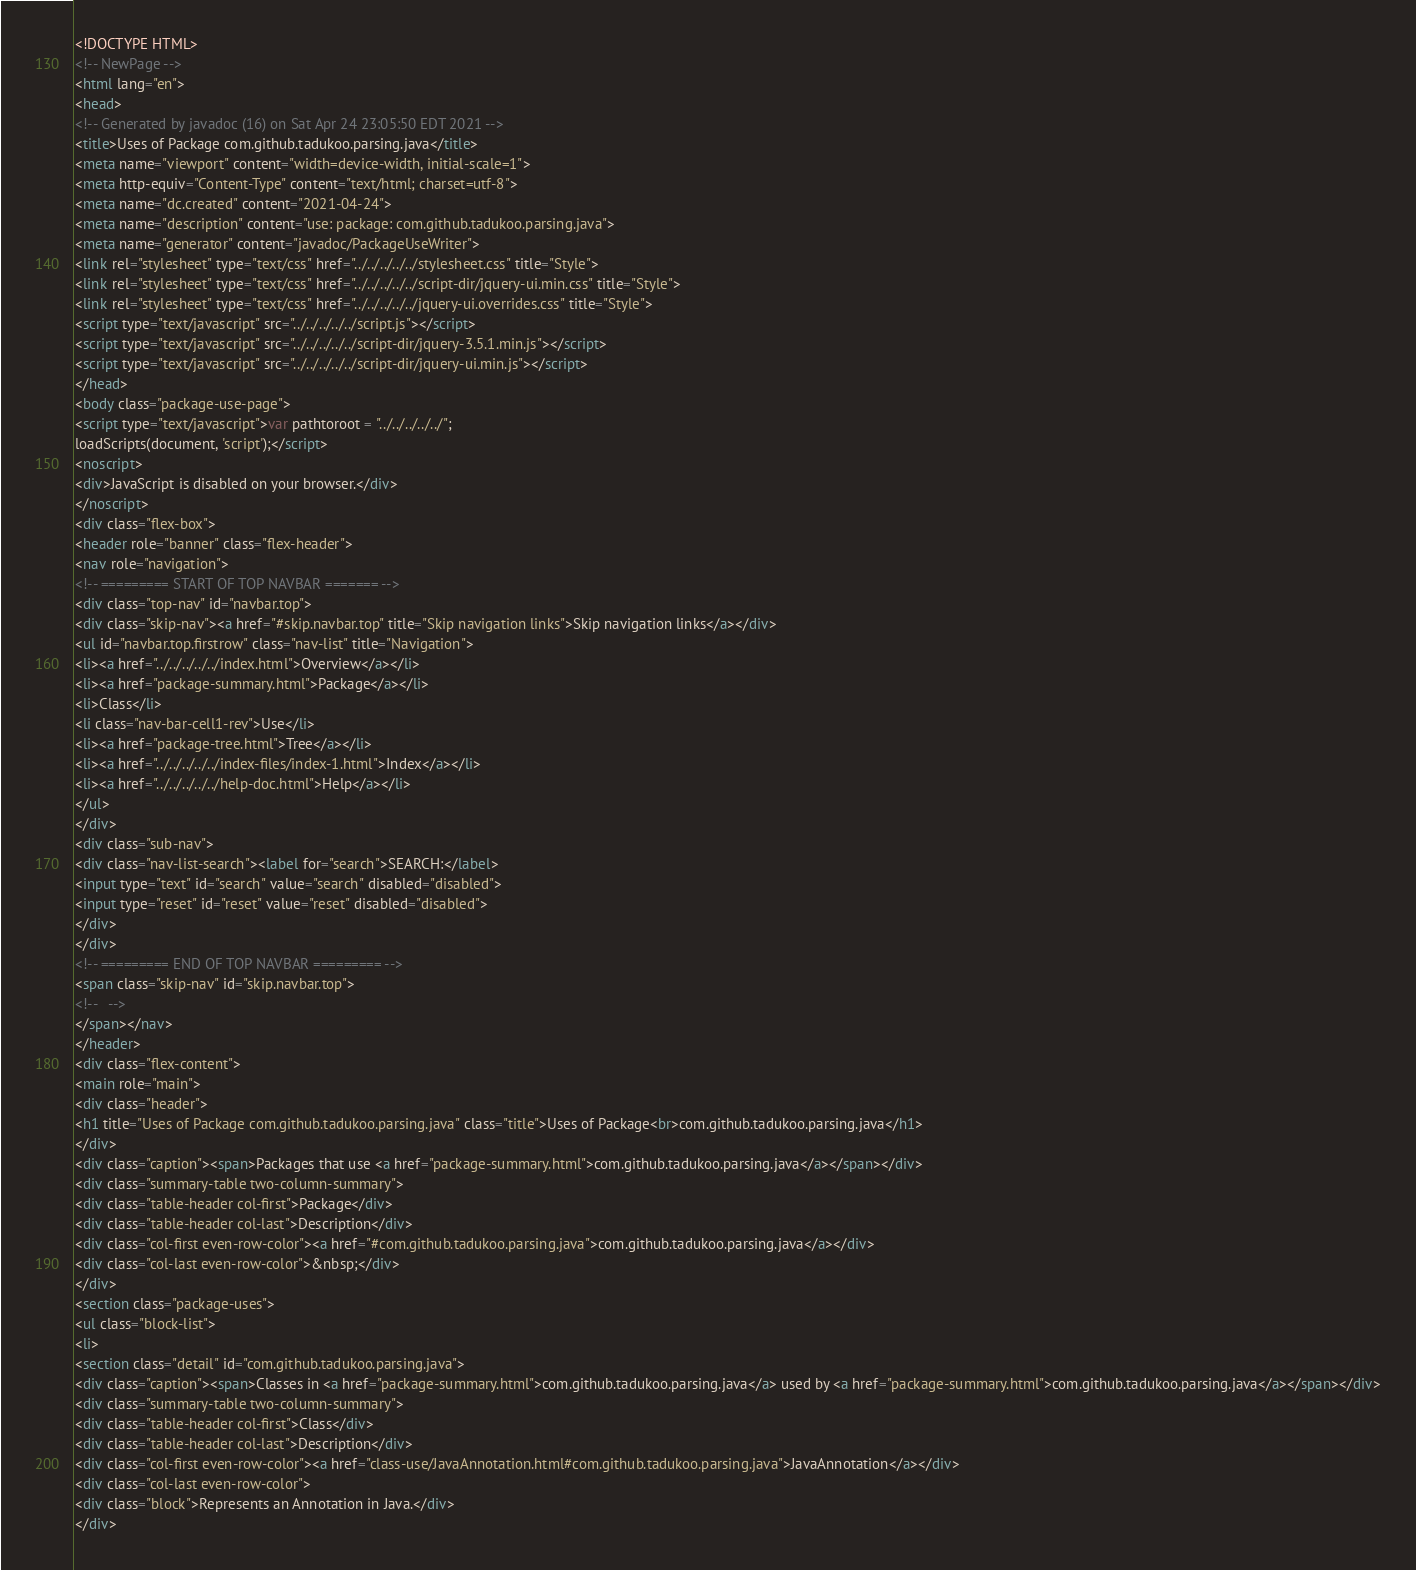<code> <loc_0><loc_0><loc_500><loc_500><_HTML_><!DOCTYPE HTML>
<!-- NewPage -->
<html lang="en">
<head>
<!-- Generated by javadoc (16) on Sat Apr 24 23:05:50 EDT 2021 -->
<title>Uses of Package com.github.tadukoo.parsing.java</title>
<meta name="viewport" content="width=device-width, initial-scale=1">
<meta http-equiv="Content-Type" content="text/html; charset=utf-8">
<meta name="dc.created" content="2021-04-24">
<meta name="description" content="use: package: com.github.tadukoo.parsing.java">
<meta name="generator" content="javadoc/PackageUseWriter">
<link rel="stylesheet" type="text/css" href="../../../../../stylesheet.css" title="Style">
<link rel="stylesheet" type="text/css" href="../../../../../script-dir/jquery-ui.min.css" title="Style">
<link rel="stylesheet" type="text/css" href="../../../../../jquery-ui.overrides.css" title="Style">
<script type="text/javascript" src="../../../../../script.js"></script>
<script type="text/javascript" src="../../../../../script-dir/jquery-3.5.1.min.js"></script>
<script type="text/javascript" src="../../../../../script-dir/jquery-ui.min.js"></script>
</head>
<body class="package-use-page">
<script type="text/javascript">var pathtoroot = "../../../../../";
loadScripts(document, 'script');</script>
<noscript>
<div>JavaScript is disabled on your browser.</div>
</noscript>
<div class="flex-box">
<header role="banner" class="flex-header">
<nav role="navigation">
<!-- ========= START OF TOP NAVBAR ======= -->
<div class="top-nav" id="navbar.top">
<div class="skip-nav"><a href="#skip.navbar.top" title="Skip navigation links">Skip navigation links</a></div>
<ul id="navbar.top.firstrow" class="nav-list" title="Navigation">
<li><a href="../../../../../index.html">Overview</a></li>
<li><a href="package-summary.html">Package</a></li>
<li>Class</li>
<li class="nav-bar-cell1-rev">Use</li>
<li><a href="package-tree.html">Tree</a></li>
<li><a href="../../../../../index-files/index-1.html">Index</a></li>
<li><a href="../../../../../help-doc.html">Help</a></li>
</ul>
</div>
<div class="sub-nav">
<div class="nav-list-search"><label for="search">SEARCH:</label>
<input type="text" id="search" value="search" disabled="disabled">
<input type="reset" id="reset" value="reset" disabled="disabled">
</div>
</div>
<!-- ========= END OF TOP NAVBAR ========= -->
<span class="skip-nav" id="skip.navbar.top">
<!--   -->
</span></nav>
</header>
<div class="flex-content">
<main role="main">
<div class="header">
<h1 title="Uses of Package com.github.tadukoo.parsing.java" class="title">Uses of Package<br>com.github.tadukoo.parsing.java</h1>
</div>
<div class="caption"><span>Packages that use <a href="package-summary.html">com.github.tadukoo.parsing.java</a></span></div>
<div class="summary-table two-column-summary">
<div class="table-header col-first">Package</div>
<div class="table-header col-last">Description</div>
<div class="col-first even-row-color"><a href="#com.github.tadukoo.parsing.java">com.github.tadukoo.parsing.java</a></div>
<div class="col-last even-row-color">&nbsp;</div>
</div>
<section class="package-uses">
<ul class="block-list">
<li>
<section class="detail" id="com.github.tadukoo.parsing.java">
<div class="caption"><span>Classes in <a href="package-summary.html">com.github.tadukoo.parsing.java</a> used by <a href="package-summary.html">com.github.tadukoo.parsing.java</a></span></div>
<div class="summary-table two-column-summary">
<div class="table-header col-first">Class</div>
<div class="table-header col-last">Description</div>
<div class="col-first even-row-color"><a href="class-use/JavaAnnotation.html#com.github.tadukoo.parsing.java">JavaAnnotation</a></div>
<div class="col-last even-row-color">
<div class="block">Represents an Annotation in Java.</div>
</div></code> 